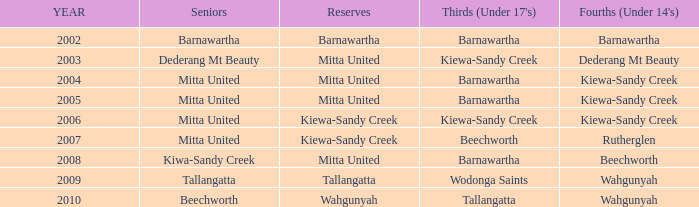Can you identify the seniors who have a membership date earlier than 2006 and are part of the kiewa-sandy creek under 14's (fourths) team? Mitta United, Mitta United. 